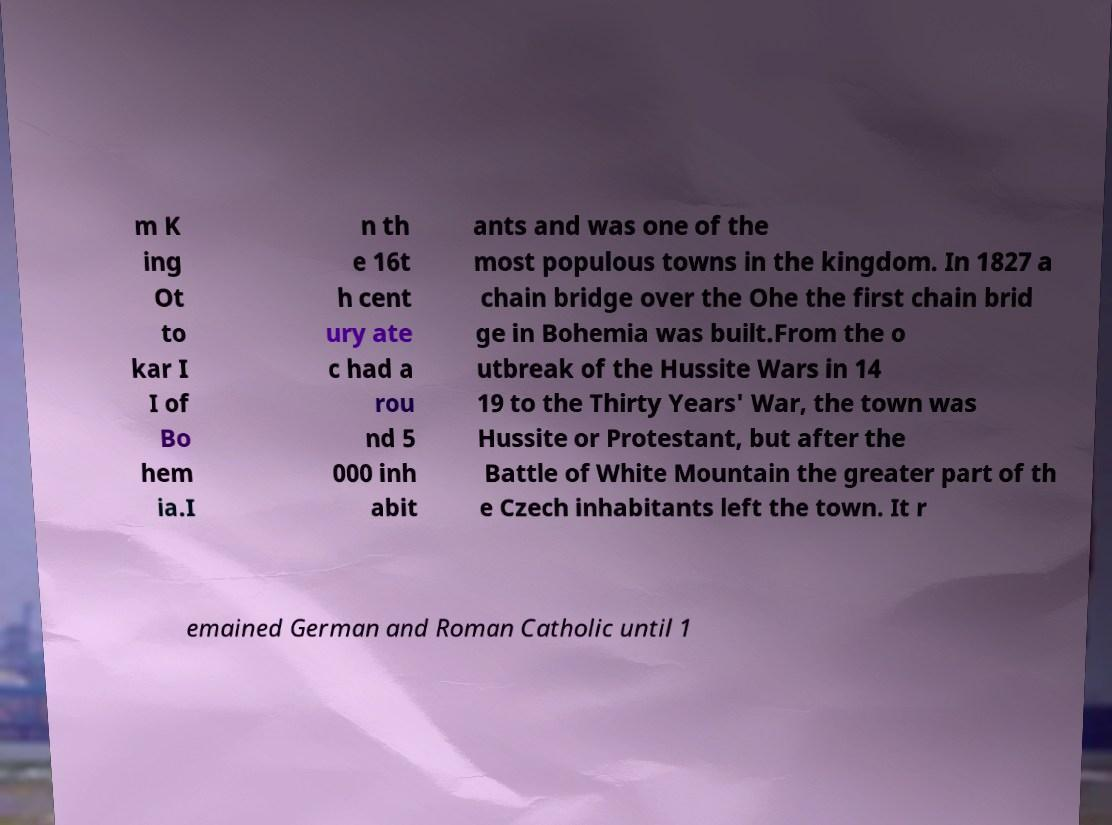I need the written content from this picture converted into text. Can you do that? m K ing Ot to kar I I of Bo hem ia.I n th e 16t h cent ury ate c had a rou nd 5 000 inh abit ants and was one of the most populous towns in the kingdom. In 1827 a chain bridge over the Ohe the first chain brid ge in Bohemia was built.From the o utbreak of the Hussite Wars in 14 19 to the Thirty Years' War, the town was Hussite or Protestant, but after the Battle of White Mountain the greater part of th e Czech inhabitants left the town. It r emained German and Roman Catholic until 1 